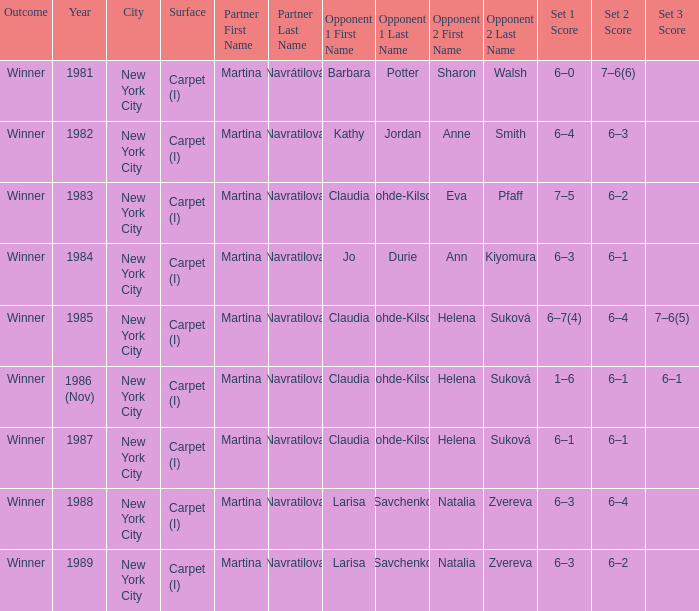How many locations hosted Claudia Kohde-Kilsch Eva Pfaff? 1.0. 